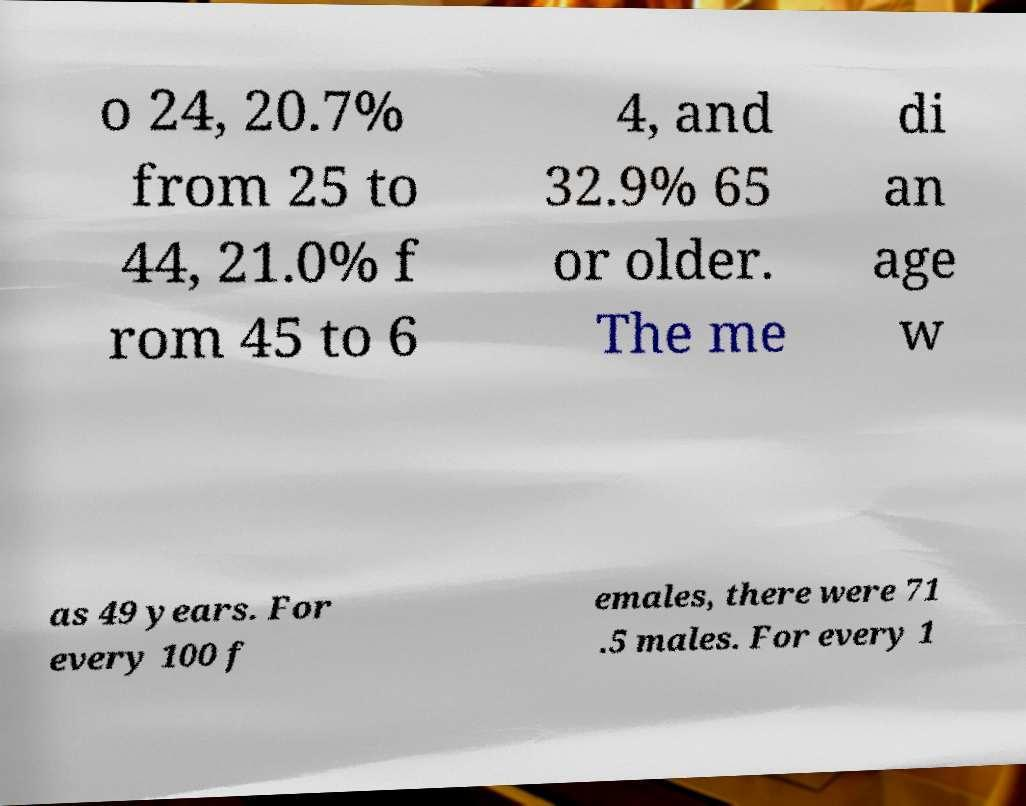Please identify and transcribe the text found in this image. o 24, 20.7% from 25 to 44, 21.0% f rom 45 to 6 4, and 32.9% 65 or older. The me di an age w as 49 years. For every 100 f emales, there were 71 .5 males. For every 1 